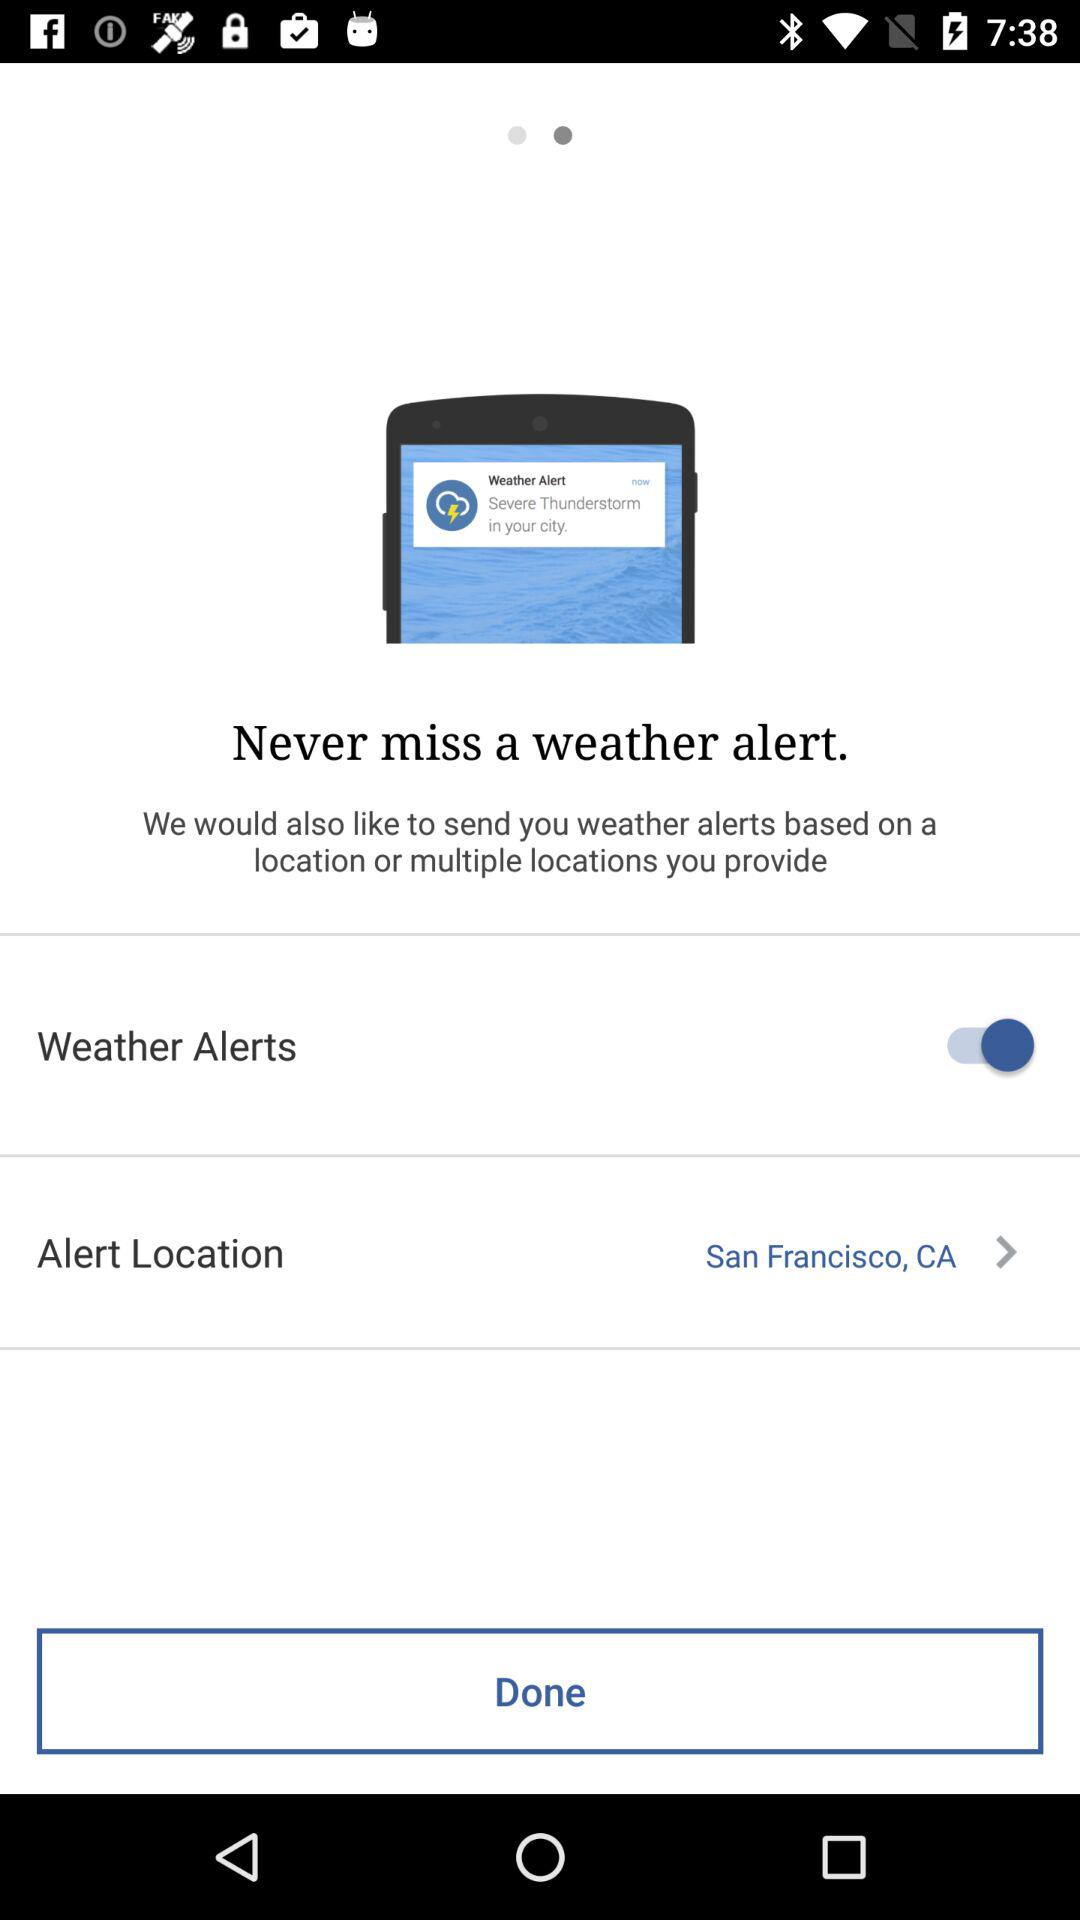What is the alert location? The alert location is San Francisco, CA. 